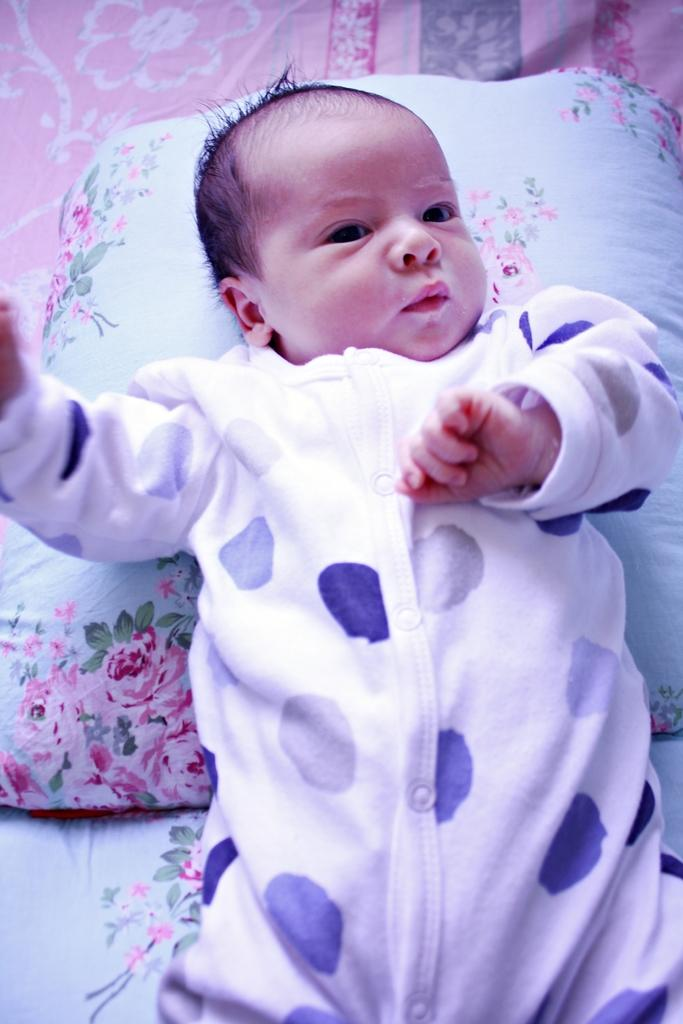What is the main subject of the image? There is a baby in the image. What is the baby laying on? The baby is laying on a pillow. Can you describe the design of the pillow? The pillow has a flower print. What is visible at the top of the image? There is a cloth at the top of the image. What is the price of the detail on the baby's clothing in the image? There is no detail or price mentioned on the baby's clothing in the image. 